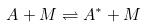Convert formula to latex. <formula><loc_0><loc_0><loc_500><loc_500>A + M \rightleftharpoons A ^ { * } + M</formula> 